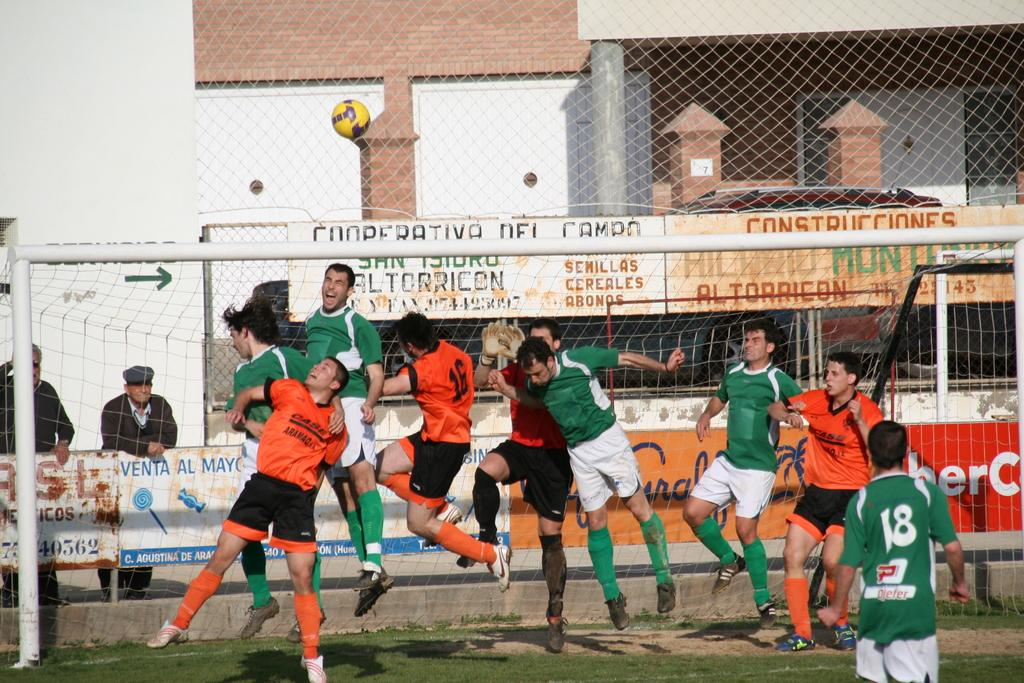<image>
Relay a brief, clear account of the picture shown. Green and orange shirted soccer players leap for the ball at the Cooperativa Del Campo soccer field. 